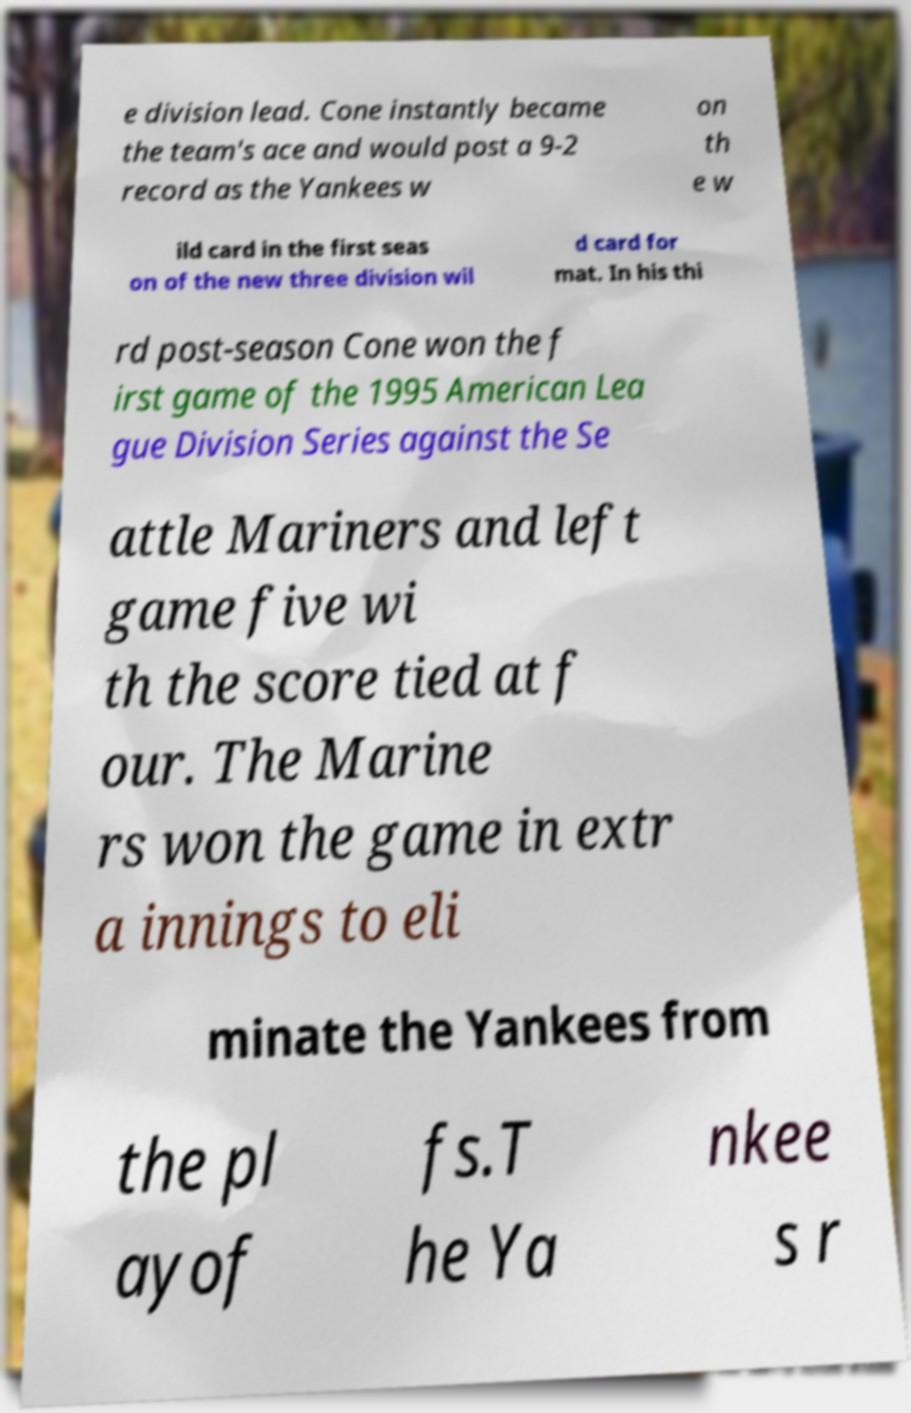There's text embedded in this image that I need extracted. Can you transcribe it verbatim? e division lead. Cone instantly became the team's ace and would post a 9-2 record as the Yankees w on th e w ild card in the first seas on of the new three division wil d card for mat. In his thi rd post-season Cone won the f irst game of the 1995 American Lea gue Division Series against the Se attle Mariners and left game five wi th the score tied at f our. The Marine rs won the game in extr a innings to eli minate the Yankees from the pl ayof fs.T he Ya nkee s r 